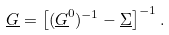Convert formula to latex. <formula><loc_0><loc_0><loc_500><loc_500>\underline { G } = \left [ ( \underline { G } ^ { 0 } ) ^ { - 1 } - \underline { \Sigma } \right ] ^ { - 1 } .</formula> 